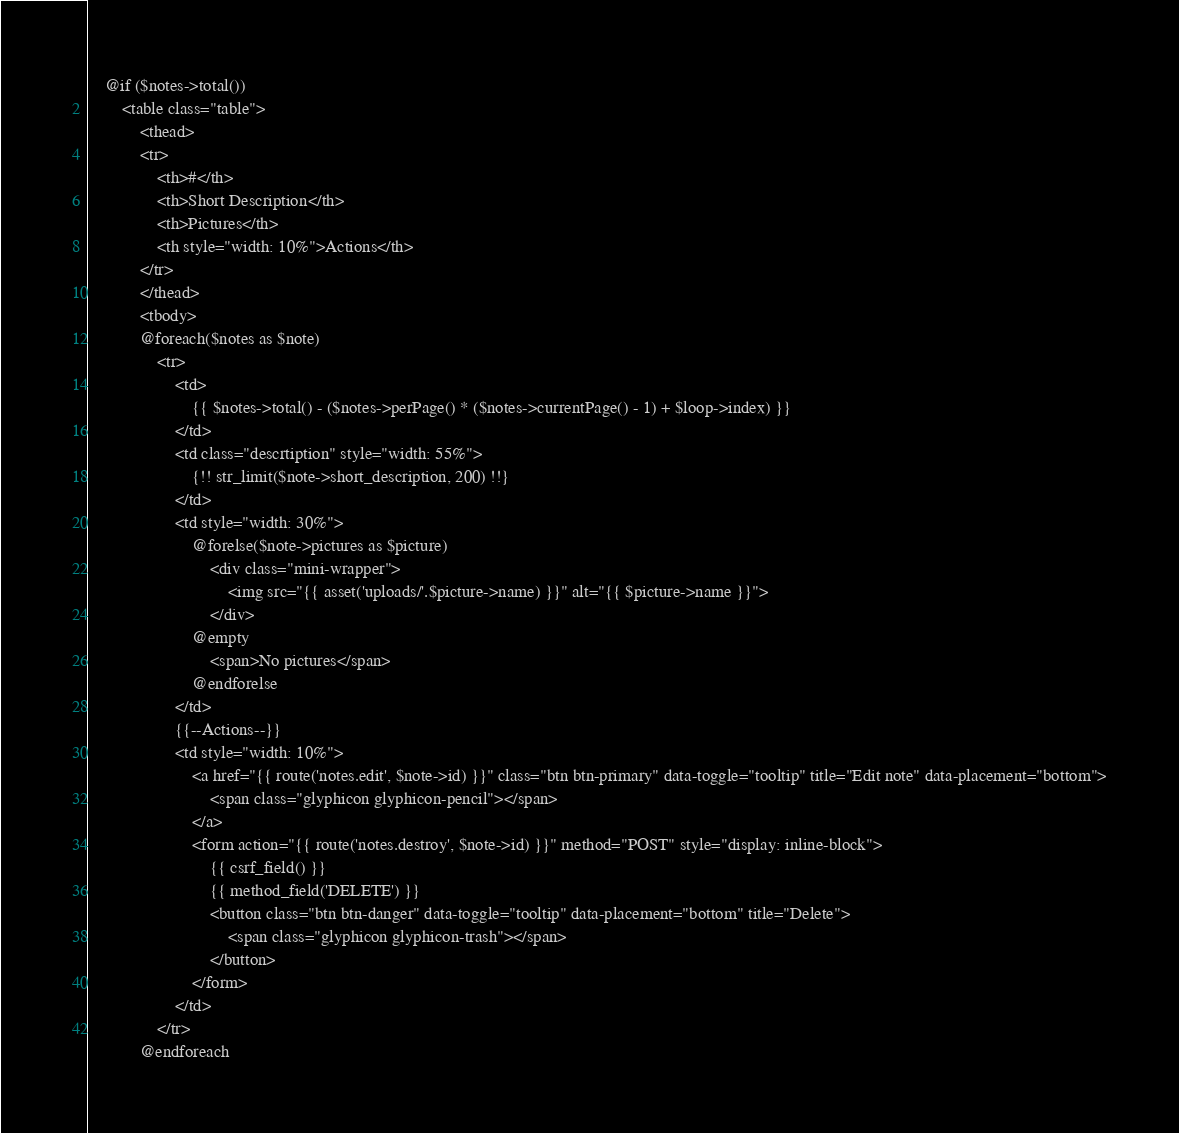Convert code to text. <code><loc_0><loc_0><loc_500><loc_500><_PHP_>    @if ($notes->total())
        <table class="table">
            <thead>
            <tr>
                <th>#</th>
                <th>Short Description</th>
                <th>Pictures</th>
                <th style="width: 10%">Actions</th>
            </tr>
            </thead>
            <tbody>
            @foreach($notes as $note)
                <tr>
                    <td>
                        {{ $notes->total() - ($notes->perPage() * ($notes->currentPage() - 1) + $loop->index) }}
                    </td>
                    <td class="descrtiption" style="width: 55%">
                        {!! str_limit($note->short_description, 200) !!}
                    </td>
                    <td style="width: 30%">
                        @forelse($note->pictures as $picture)
                            <div class="mini-wrapper">
                                <img src="{{ asset('uploads/'.$picture->name) }}" alt="{{ $picture->name }}">
                            </div>
                        @empty
                            <span>No pictures</span>
                        @endforelse
                    </td>
                    {{--Actions--}}
                    <td style="width: 10%">
                        <a href="{{ route('notes.edit', $note->id) }}" class="btn btn-primary" data-toggle="tooltip" title="Edit note" data-placement="bottom">
                            <span class="glyphicon glyphicon-pencil"></span>
                        </a>
                        <form action="{{ route('notes.destroy', $note->id) }}" method="POST" style="display: inline-block">
                            {{ csrf_field() }}
                            {{ method_field('DELETE') }}
                            <button class="btn btn-danger" data-toggle="tooltip" data-placement="bottom" title="Delete">
                                <span class="glyphicon glyphicon-trash"></span>
                            </button>
                        </form>
                    </td>
                </tr>
            @endforeach</code> 